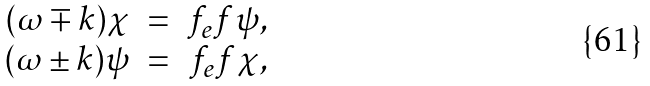<formula> <loc_0><loc_0><loc_500><loc_500>\begin{array} { r c r } ( \omega \mp k ) \chi & = & f _ { e } f \psi , \\ ( \omega \pm k ) \psi & = & f _ { e } f \chi , \\ \end{array}</formula> 